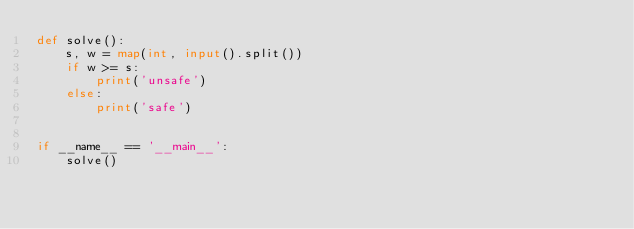<code> <loc_0><loc_0><loc_500><loc_500><_Python_>def solve():
    s, w = map(int, input().split())
    if w >= s:
        print('unsafe')
    else:
        print('safe')


if __name__ == '__main__':
    solve()
</code> 